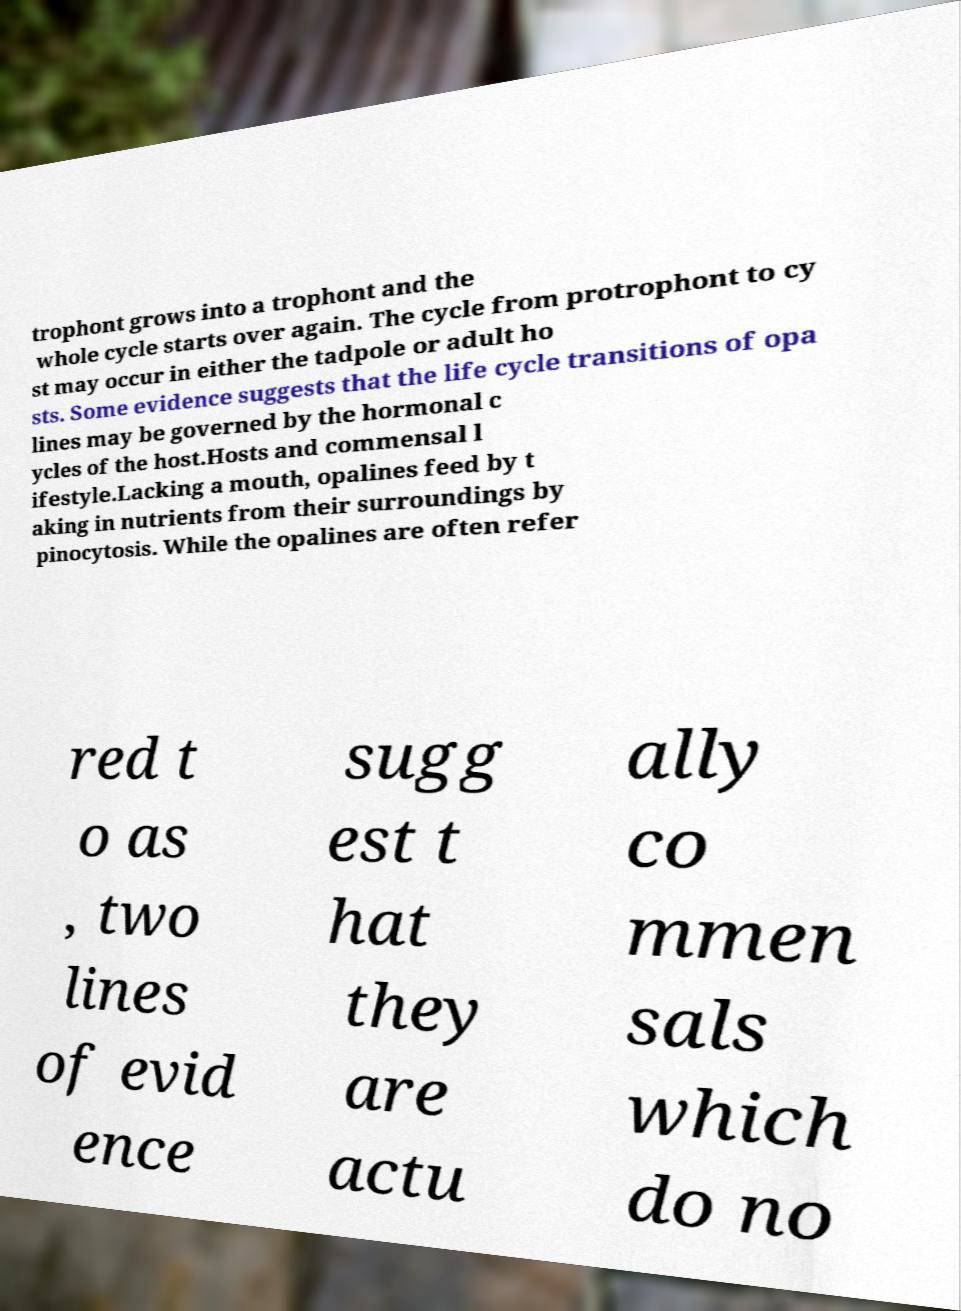Please read and relay the text visible in this image. What does it say? trophont grows into a trophont and the whole cycle starts over again. The cycle from protrophont to cy st may occur in either the tadpole or adult ho sts. Some evidence suggests that the life cycle transitions of opa lines may be governed by the hormonal c ycles of the host.Hosts and commensal l ifestyle.Lacking a mouth, opalines feed by t aking in nutrients from their surroundings by pinocytosis. While the opalines are often refer red t o as , two lines of evid ence sugg est t hat they are actu ally co mmen sals which do no 